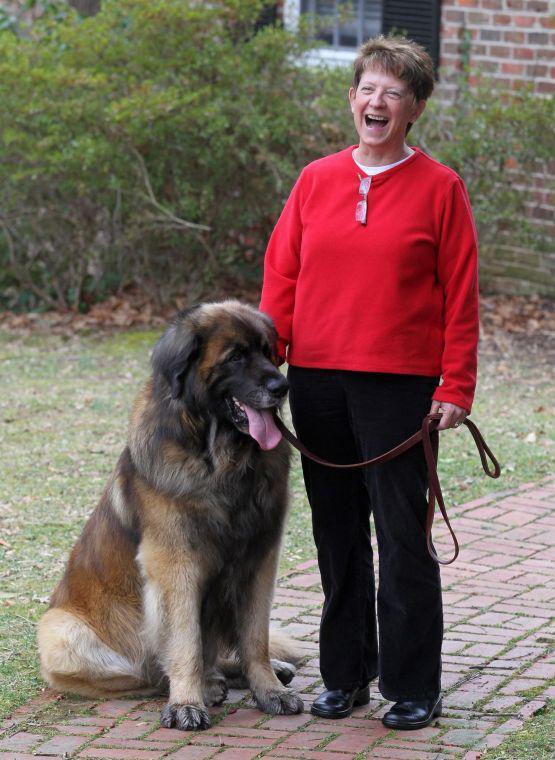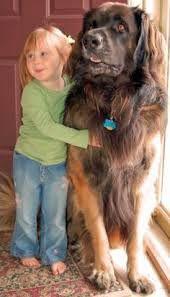The first image is the image on the left, the second image is the image on the right. Analyze the images presented: Is the assertion "There is one adult human in the image on the left" valid? Answer yes or no. Yes. The first image is the image on the left, the second image is the image on the right. Assess this claim about the two images: "Only one image is of a dog with no people present.". Correct or not? Answer yes or no. No. 